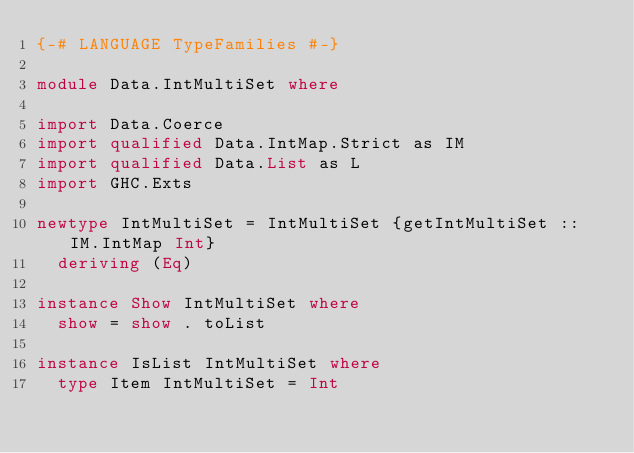<code> <loc_0><loc_0><loc_500><loc_500><_Haskell_>{-# LANGUAGE TypeFamilies #-}

module Data.IntMultiSet where

import Data.Coerce
import qualified Data.IntMap.Strict as IM
import qualified Data.List as L
import GHC.Exts

newtype IntMultiSet = IntMultiSet {getIntMultiSet :: IM.IntMap Int}
  deriving (Eq)

instance Show IntMultiSet where
  show = show . toList

instance IsList IntMultiSet where
  type Item IntMultiSet = Int</code> 